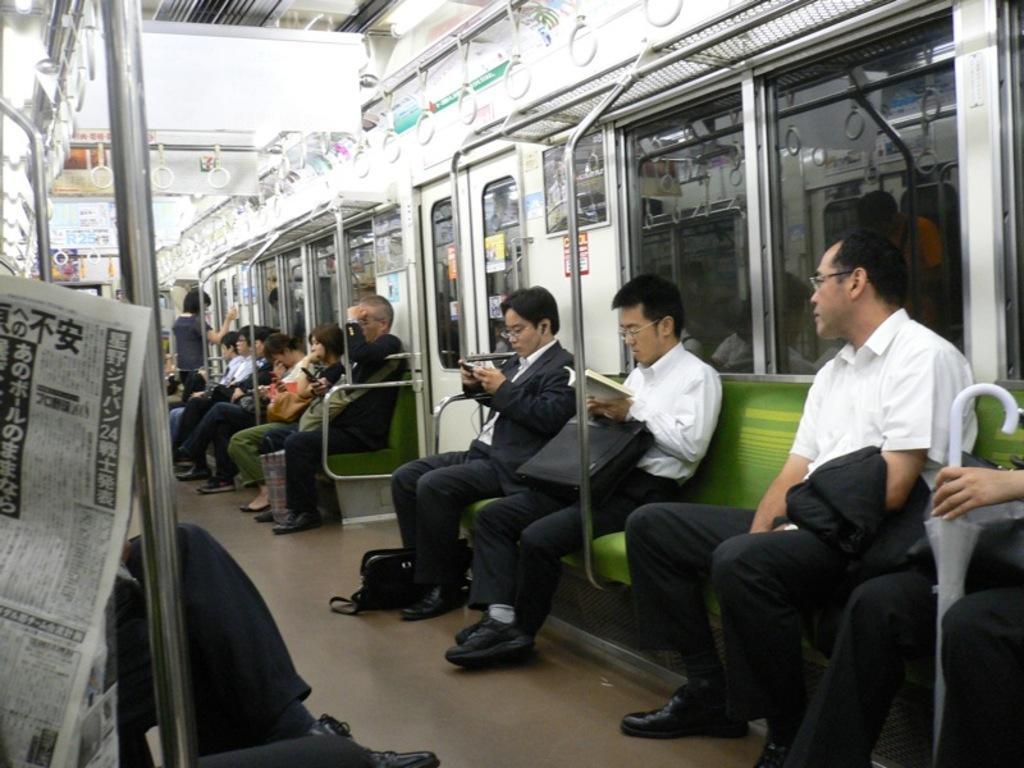What type of vehicle is the image taken inside? The image is inside a train. What are the people in the image doing? There are people sitting on benches in the image. What can be seen on the left side of the image? There is a paper visible on the left side of the image. What structural elements can be seen in the image? There are rods and a door in the image. What type of windows are present in the image? There are glass windows in the image. What type of party is happening in the image? There is no party happening in the image; it is a scene inside a train with people sitting on benches. Can you tell me who the partner of the person sitting on the right bench is? There is no indication of a partner or relationship between the people in the image; they are simply sitting on benches. 